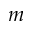Convert formula to latex. <formula><loc_0><loc_0><loc_500><loc_500>m</formula> 